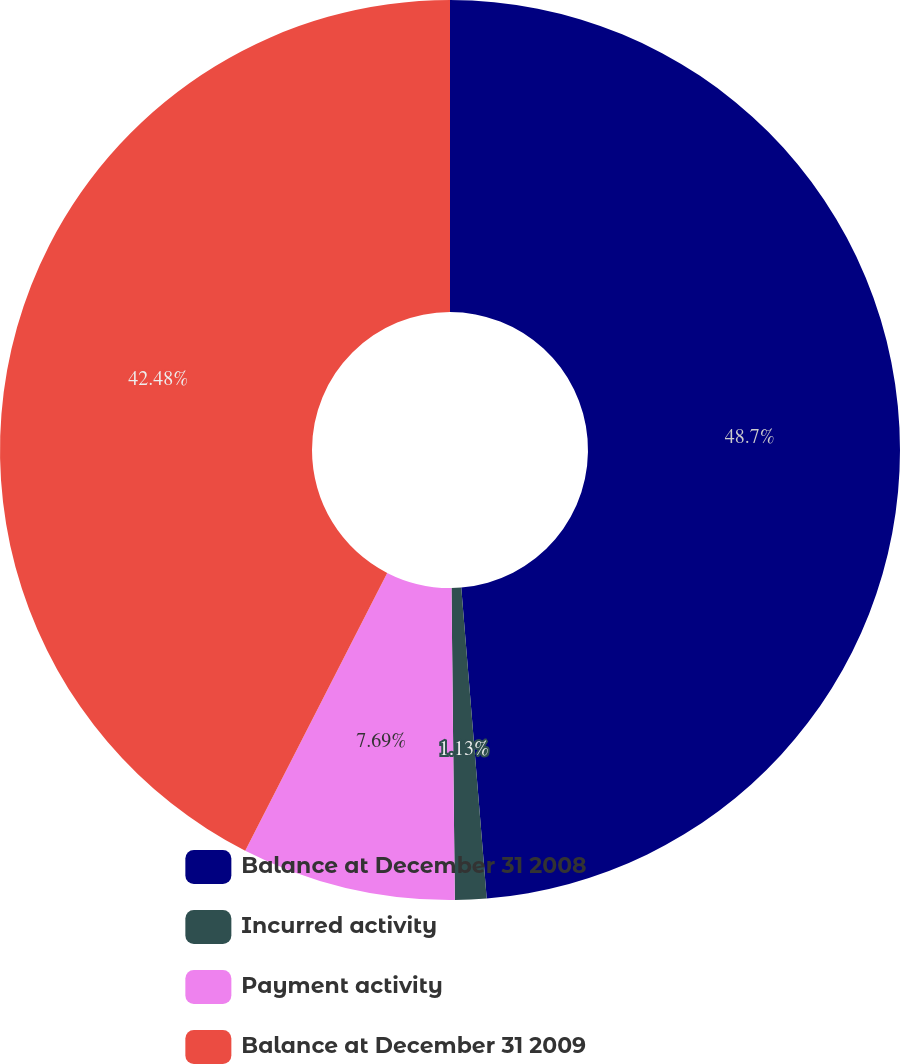Convert chart to OTSL. <chart><loc_0><loc_0><loc_500><loc_500><pie_chart><fcel>Balance at December 31 2008<fcel>Incurred activity<fcel>Payment activity<fcel>Balance at December 31 2009<nl><fcel>48.7%<fcel>1.13%<fcel>7.69%<fcel>42.48%<nl></chart> 